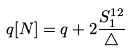Convert formula to latex. <formula><loc_0><loc_0><loc_500><loc_500>q [ N ] = q + 2 \frac { S _ { 1 } ^ { 1 2 } } { \triangle }</formula> 